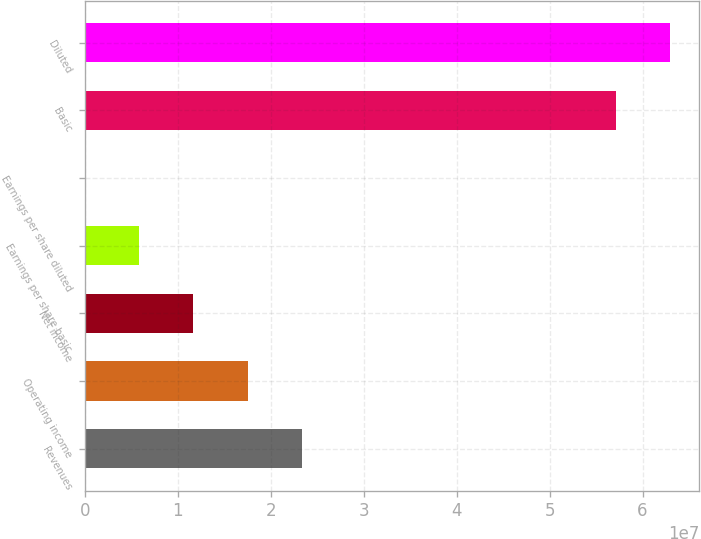Convert chart. <chart><loc_0><loc_0><loc_500><loc_500><bar_chart><fcel>Revenues<fcel>Operating income<fcel>Net income<fcel>Earnings per share basic<fcel>Earnings per share diluted<fcel>Basic<fcel>Diluted<nl><fcel>2.33448e+07<fcel>1.75086e+07<fcel>1.16724e+07<fcel>5.8362e+06<fcel>0.31<fcel>5.71329e+07<fcel>6.29691e+07<nl></chart> 